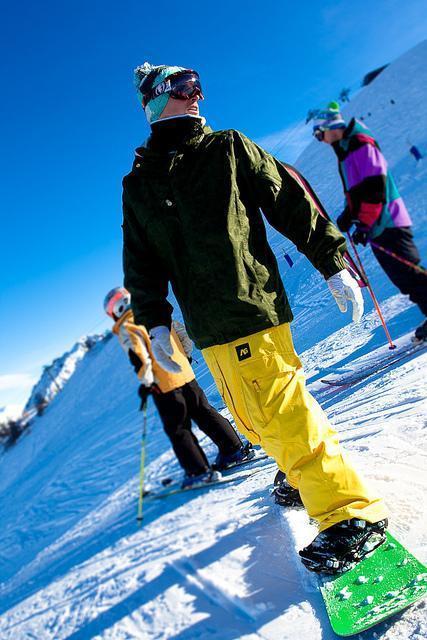How many people can you see?
Give a very brief answer. 3. 